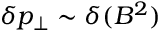<formula> <loc_0><loc_0><loc_500><loc_500>\delta p _ { \perp } \sim \delta ( B ^ { 2 } )</formula> 